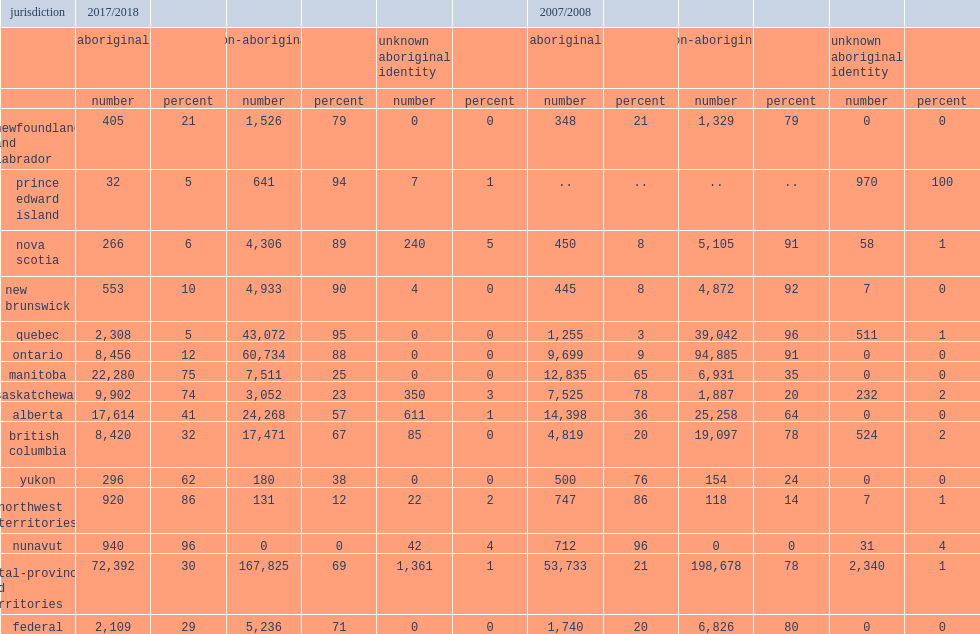What was the percentage of admissions to provincial/territorial custody aboriginal adults accounted for in 2017/2018? 30.0. What was the percentage of admissions to federal custody aboriginal adults accounted for in 2017/2018? 29.0. What was the percentage of admissions to provincial/territorial custody that aboriginal adults represented in 2007/2008? 21.0. What was the percentage of admissions to federal custody that aboriginal adults represented in 2007/2008? 20.0. What was the percentage of admissions to custody in manitoba that aboriginal adults represented in 2017/2018? 75.0. What was the percentage of admissions to custody in saskatchewan that aboriginal adults represented in 2017/2018? 74.0. 